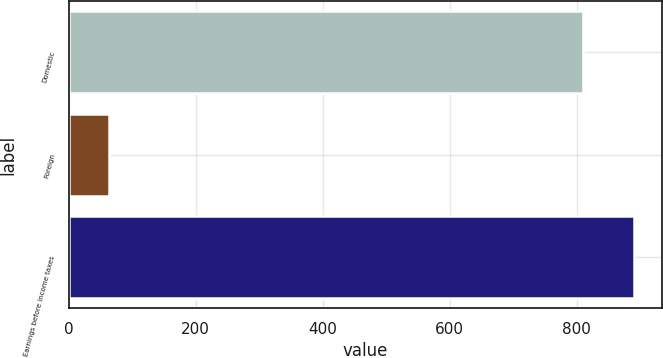Convert chart to OTSL. <chart><loc_0><loc_0><loc_500><loc_500><bar_chart><fcel>Domestic<fcel>Foreign<fcel>Earnings before income taxes<nl><fcel>809.4<fcel>63.7<fcel>890.34<nl></chart> 